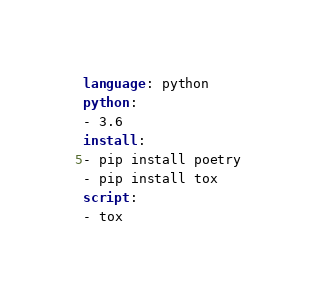Convert code to text. <code><loc_0><loc_0><loc_500><loc_500><_YAML_>language: python
python:
- 3.6
install:
- pip install poetry
- pip install tox
script:
- tox</code> 